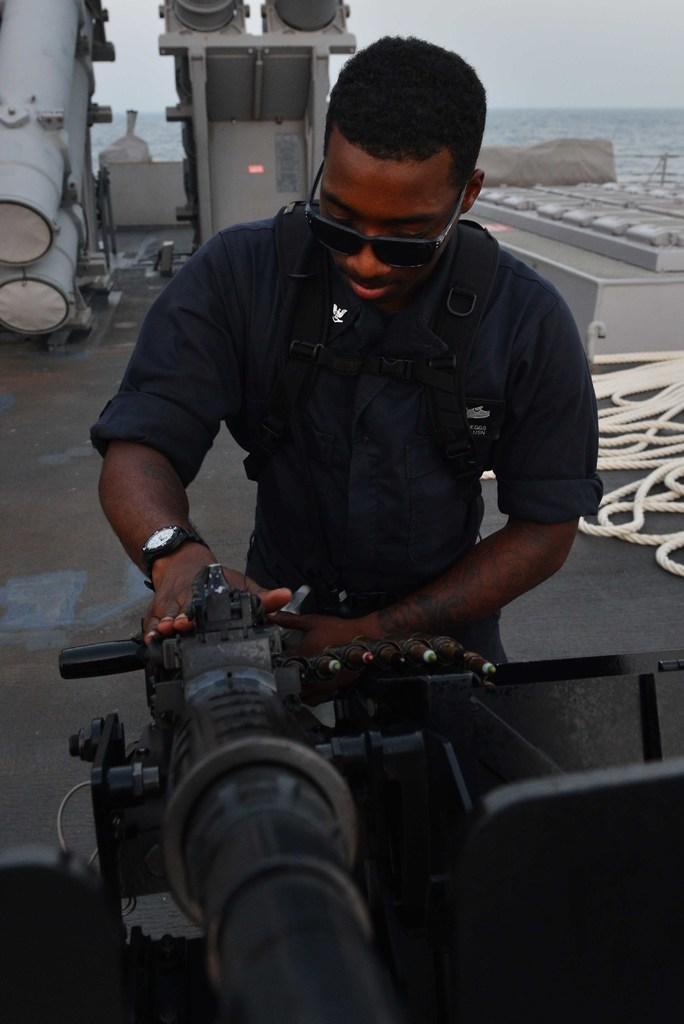Can you describe this image briefly? In this image we can see a man is holding a weapon in his hands. In the background there are metal objects, rope on the floor, water and sky. 